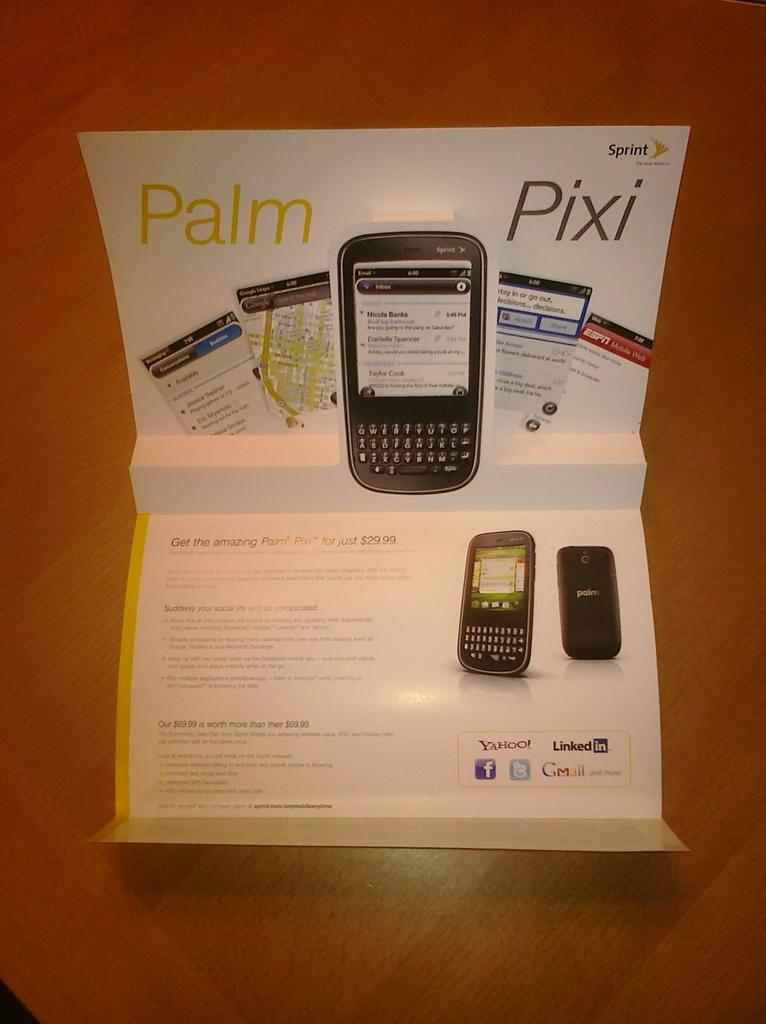<image>
Render a clear and concise summary of the photo. Display for a phone that says "Palm Pixi" on it. 